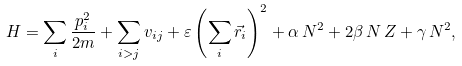<formula> <loc_0><loc_0><loc_500><loc_500>H = \sum _ { i } \frac { p _ { i } ^ { 2 } } { 2 m } + \sum _ { i > j } v _ { i j } + \varepsilon \left ( \sum _ { i } \vec { r } _ { i } \right ) ^ { 2 } + \alpha \, { N } ^ { 2 } + 2 \beta \, { N } \, { Z } + \gamma \, { N } ^ { 2 } ,</formula> 